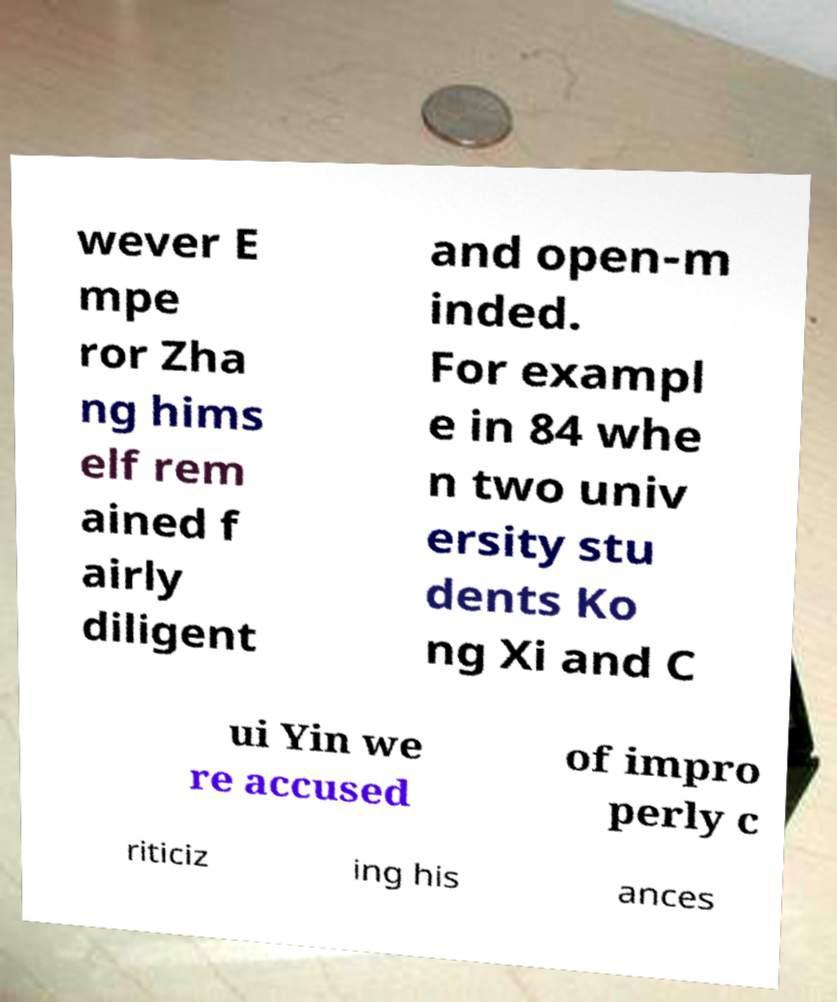For documentation purposes, I need the text within this image transcribed. Could you provide that? wever E mpe ror Zha ng hims elf rem ained f airly diligent and open-m inded. For exampl e in 84 whe n two univ ersity stu dents Ko ng Xi and C ui Yin we re accused of impro perly c riticiz ing his ances 